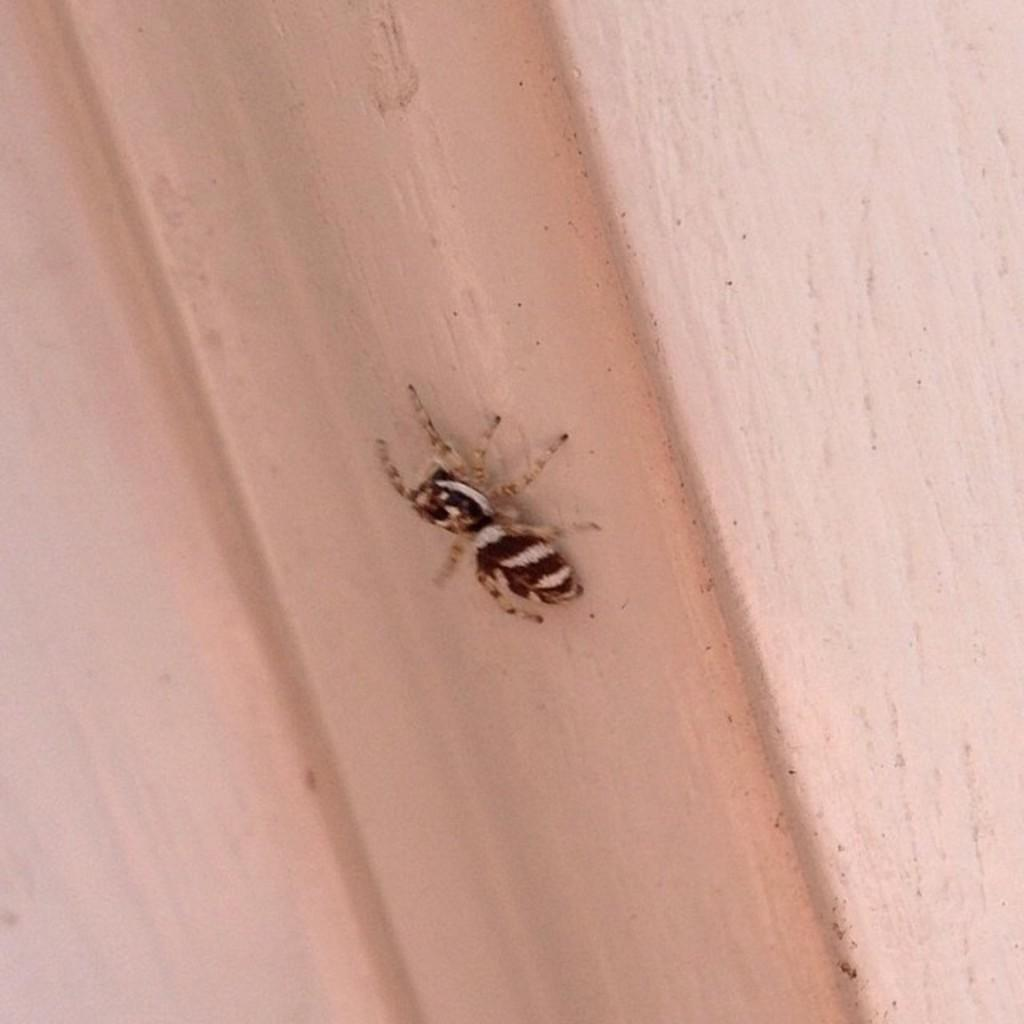What is the main subject in the center of the image? There is a spider in the center of the image. Where is the spider located? The spider is on a wall. What type of silver pickle is the spider holding in the image? There is no silver pickle present in the image, and the spider is not holding anything. Is there a doll sitting next to the spider in the image? There is no doll present in the image. 